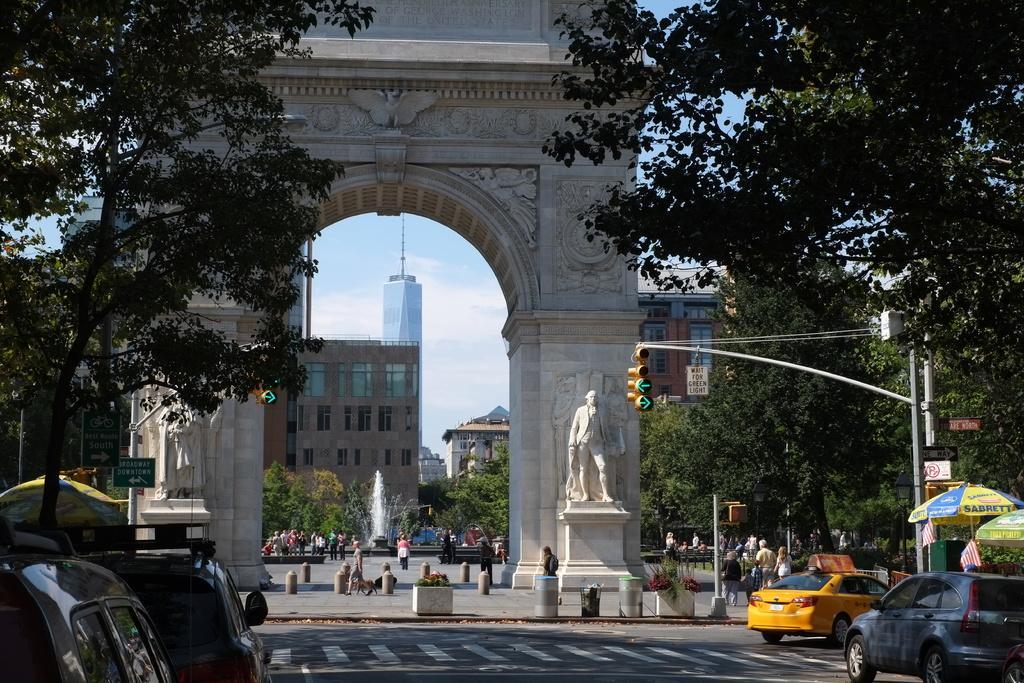Please provide a concise description of this image. In this image we can see the arch with the statues. We can also see the safety pillars, vehicles, traffic signal light poles, trees, sign boards, buildings and also the water fountain. We can also see the people on the road. Image also consists of the umbrellas for shelter. We can also see the flags, plants and also the trash bin. Sky is also visible with some clouds. 